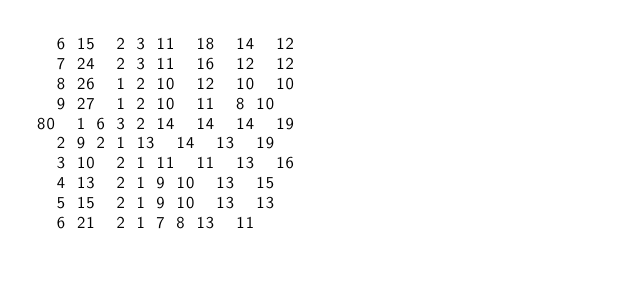Convert code to text. <code><loc_0><loc_0><loc_500><loc_500><_ObjectiveC_>	6	15	2	3	11	18	14	12	
	7	24	2	3	11	16	12	12	
	8	26	1	2	10	12	10	10	
	9	27	1	2	10	11	8	10	
80	1	6	3	2	14	14	14	19	
	2	9	2	1	13	14	13	19	
	3	10	2	1	11	11	13	16	
	4	13	2	1	9	10	13	15	
	5	15	2	1	9	10	13	13	
	6	21	2	1	7	8	13	11	</code> 